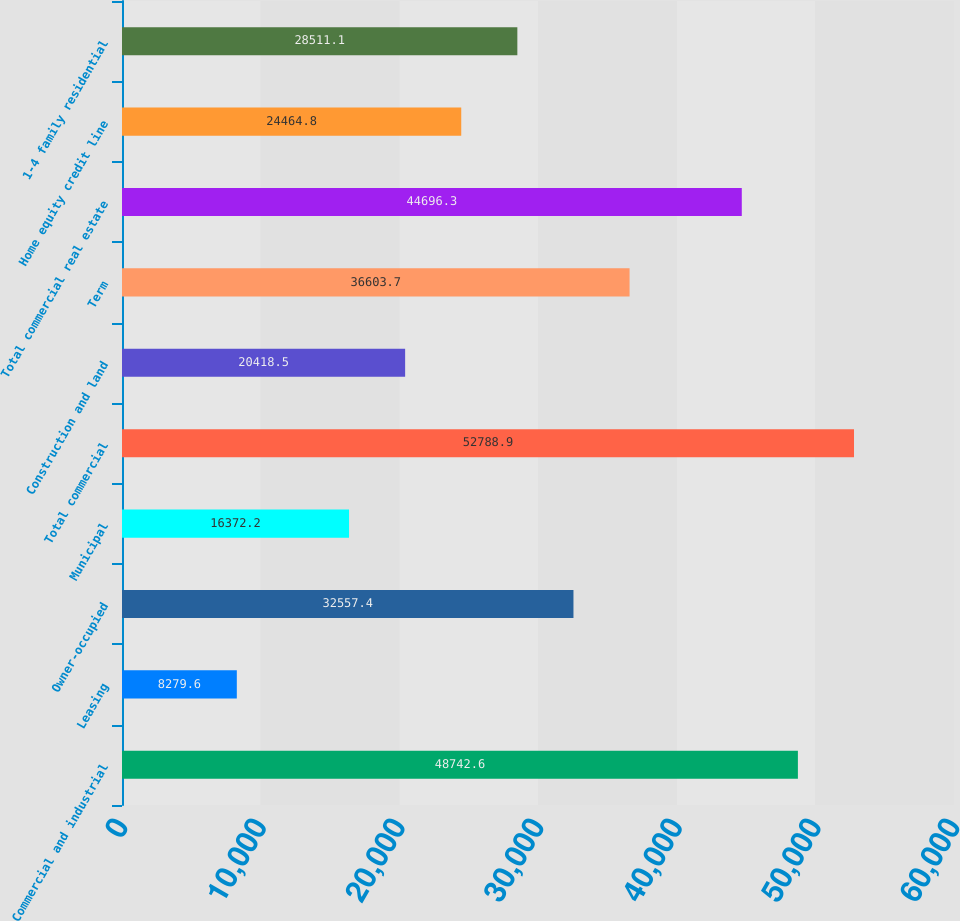<chart> <loc_0><loc_0><loc_500><loc_500><bar_chart><fcel>Commercial and industrial<fcel>Leasing<fcel>Owner-occupied<fcel>Municipal<fcel>Total commercial<fcel>Construction and land<fcel>Term<fcel>Total commercial real estate<fcel>Home equity credit line<fcel>1-4 family residential<nl><fcel>48742.6<fcel>8279.6<fcel>32557.4<fcel>16372.2<fcel>52788.9<fcel>20418.5<fcel>36603.7<fcel>44696.3<fcel>24464.8<fcel>28511.1<nl></chart> 